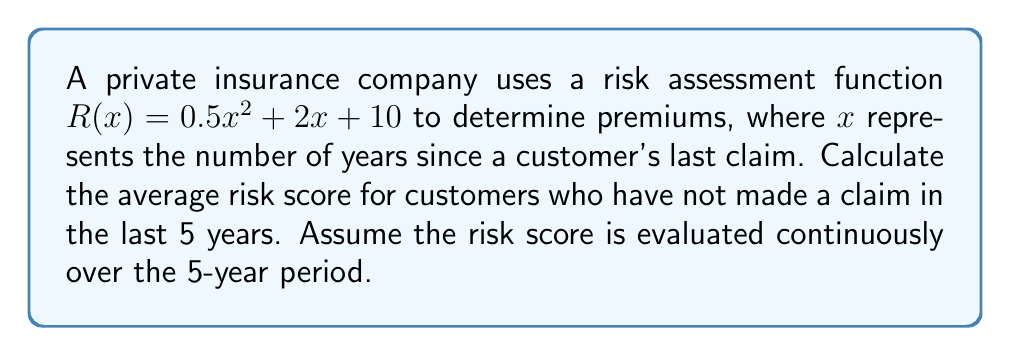What is the answer to this math problem? To solve this problem, we need to compute the definite integral of the risk assessment function $R(x)$ over the interval $[0, 5]$ and then divide by the length of the interval to find the average.

1. The risk assessment function is given as:
   $R(x) = 0.5x^2 + 2x + 10$

2. To find the average, we need to calculate:
   $\frac{1}{5} \int_{0}^{5} R(x) dx$

3. Let's compute the indefinite integral of $R(x)$:
   $$\int R(x) dx = \int (0.5x^2 + 2x + 10) dx = \frac{1}{6}x^3 + x^2 + 10x + C$$

4. Now, let's evaluate the definite integral:
   $$\begin{align*}
   \int_{0}^{5} R(x) dx &= [\frac{1}{6}x^3 + x^2 + 10x]_{0}^{5} \\
   &= (\frac{1}{6}(5^3) + 5^2 + 10(5)) - (\frac{1}{6}(0^3) + 0^2 + 10(0)) \\
   &= (\frac{125}{6} + 25 + 50) - 0 \\
   &= \frac{125}{6} + 75 \\
   &= \frac{575}{6}
   \end{align*}$$

5. To find the average, we divide by the length of the interval (5 years):
   $$\text{Average} = \frac{1}{5} \cdot \frac{575}{6} = \frac{115}{6} \approx 19.17$$

This result shows that the average risk score for customers who haven't made a claim in the last 5 years is approximately 19.17.
Answer: The average risk score is $\frac{115}{6}$ or approximately 19.17. 